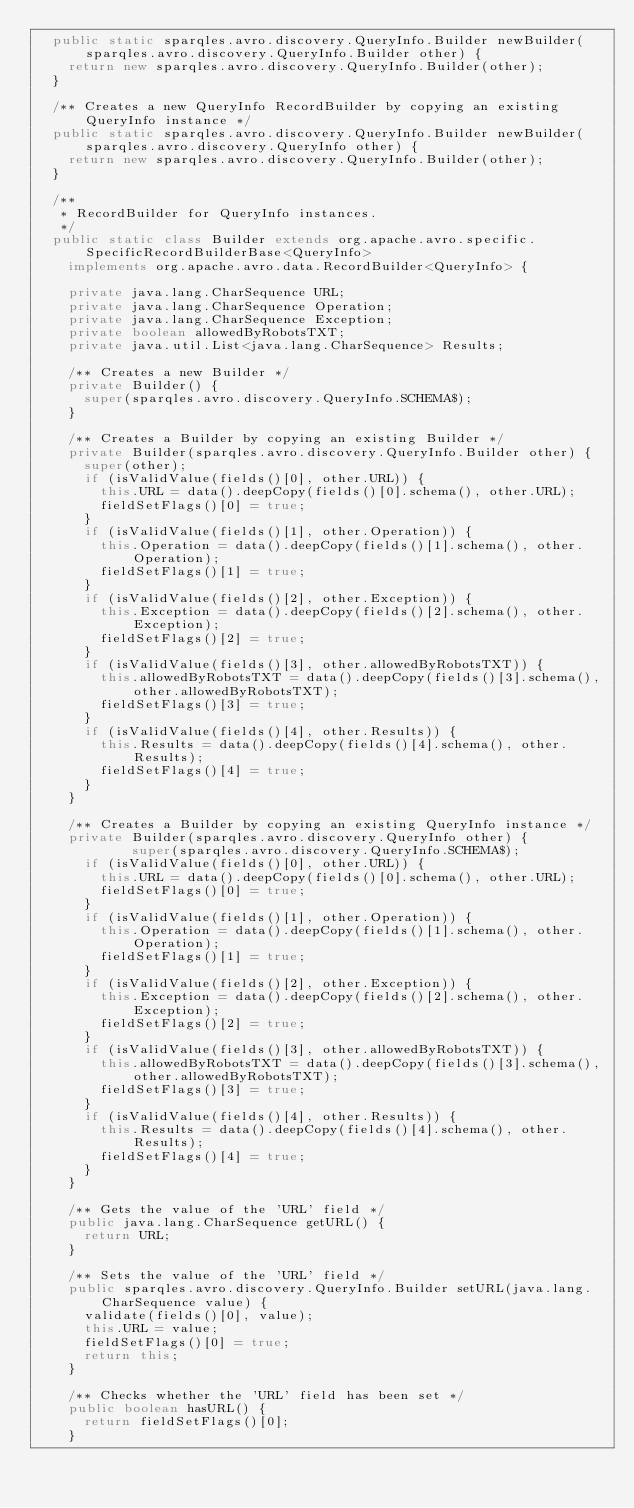<code> <loc_0><loc_0><loc_500><loc_500><_Java_>  public static sparqles.avro.discovery.QueryInfo.Builder newBuilder(sparqles.avro.discovery.QueryInfo.Builder other) {
    return new sparqles.avro.discovery.QueryInfo.Builder(other);
  }
  
  /** Creates a new QueryInfo RecordBuilder by copying an existing QueryInfo instance */
  public static sparqles.avro.discovery.QueryInfo.Builder newBuilder(sparqles.avro.discovery.QueryInfo other) {
    return new sparqles.avro.discovery.QueryInfo.Builder(other);
  }
  
  /**
   * RecordBuilder for QueryInfo instances.
   */
  public static class Builder extends org.apache.avro.specific.SpecificRecordBuilderBase<QueryInfo>
    implements org.apache.avro.data.RecordBuilder<QueryInfo> {

    private java.lang.CharSequence URL;
    private java.lang.CharSequence Operation;
    private java.lang.CharSequence Exception;
    private boolean allowedByRobotsTXT;
    private java.util.List<java.lang.CharSequence> Results;

    /** Creates a new Builder */
    private Builder() {
      super(sparqles.avro.discovery.QueryInfo.SCHEMA$);
    }
    
    /** Creates a Builder by copying an existing Builder */
    private Builder(sparqles.avro.discovery.QueryInfo.Builder other) {
      super(other);
      if (isValidValue(fields()[0], other.URL)) {
        this.URL = data().deepCopy(fields()[0].schema(), other.URL);
        fieldSetFlags()[0] = true;
      }
      if (isValidValue(fields()[1], other.Operation)) {
        this.Operation = data().deepCopy(fields()[1].schema(), other.Operation);
        fieldSetFlags()[1] = true;
      }
      if (isValidValue(fields()[2], other.Exception)) {
        this.Exception = data().deepCopy(fields()[2].schema(), other.Exception);
        fieldSetFlags()[2] = true;
      }
      if (isValidValue(fields()[3], other.allowedByRobotsTXT)) {
        this.allowedByRobotsTXT = data().deepCopy(fields()[3].schema(), other.allowedByRobotsTXT);
        fieldSetFlags()[3] = true;
      }
      if (isValidValue(fields()[4], other.Results)) {
        this.Results = data().deepCopy(fields()[4].schema(), other.Results);
        fieldSetFlags()[4] = true;
      }
    }
    
    /** Creates a Builder by copying an existing QueryInfo instance */
    private Builder(sparqles.avro.discovery.QueryInfo other) {
            super(sparqles.avro.discovery.QueryInfo.SCHEMA$);
      if (isValidValue(fields()[0], other.URL)) {
        this.URL = data().deepCopy(fields()[0].schema(), other.URL);
        fieldSetFlags()[0] = true;
      }
      if (isValidValue(fields()[1], other.Operation)) {
        this.Operation = data().deepCopy(fields()[1].schema(), other.Operation);
        fieldSetFlags()[1] = true;
      }
      if (isValidValue(fields()[2], other.Exception)) {
        this.Exception = data().deepCopy(fields()[2].schema(), other.Exception);
        fieldSetFlags()[2] = true;
      }
      if (isValidValue(fields()[3], other.allowedByRobotsTXT)) {
        this.allowedByRobotsTXT = data().deepCopy(fields()[3].schema(), other.allowedByRobotsTXT);
        fieldSetFlags()[3] = true;
      }
      if (isValidValue(fields()[4], other.Results)) {
        this.Results = data().deepCopy(fields()[4].schema(), other.Results);
        fieldSetFlags()[4] = true;
      }
    }

    /** Gets the value of the 'URL' field */
    public java.lang.CharSequence getURL() {
      return URL;
    }
    
    /** Sets the value of the 'URL' field */
    public sparqles.avro.discovery.QueryInfo.Builder setURL(java.lang.CharSequence value) {
      validate(fields()[0], value);
      this.URL = value;
      fieldSetFlags()[0] = true;
      return this; 
    }
    
    /** Checks whether the 'URL' field has been set */
    public boolean hasURL() {
      return fieldSetFlags()[0];
    }
    </code> 